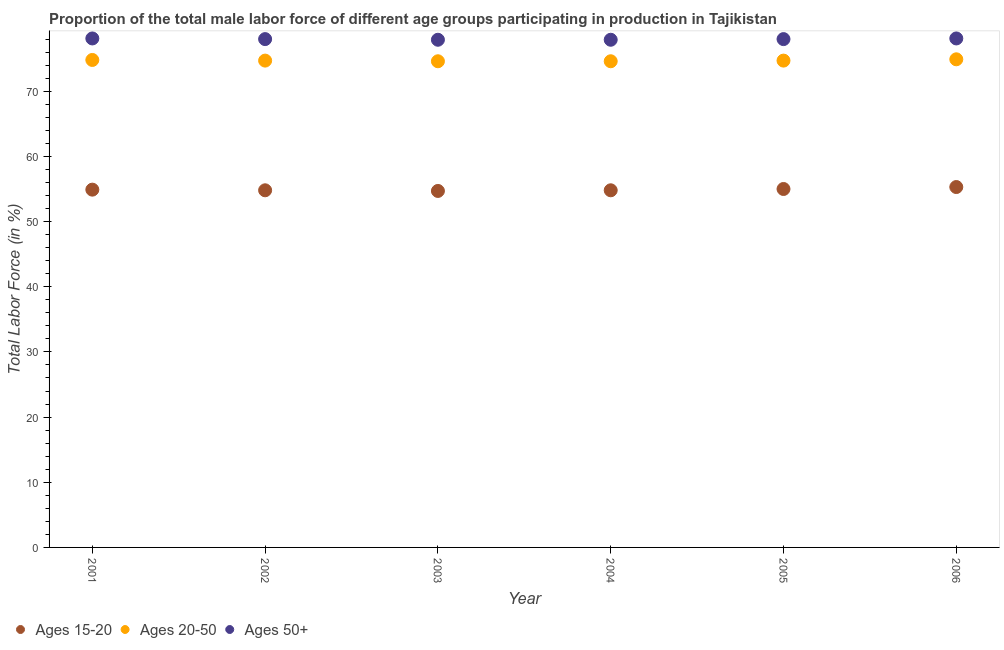What is the percentage of male labor force within the age group 15-20 in 2001?
Ensure brevity in your answer.  54.9. Across all years, what is the maximum percentage of male labor force above age 50?
Provide a short and direct response. 78.1. Across all years, what is the minimum percentage of male labor force above age 50?
Keep it short and to the point. 77.9. In which year was the percentage of male labor force above age 50 maximum?
Make the answer very short. 2001. In which year was the percentage of male labor force above age 50 minimum?
Provide a succinct answer. 2003. What is the total percentage of male labor force above age 50 in the graph?
Offer a terse response. 468. What is the difference between the percentage of male labor force within the age group 15-20 in 2001 and the percentage of male labor force within the age group 20-50 in 2002?
Provide a short and direct response. -19.8. What is the average percentage of male labor force within the age group 20-50 per year?
Keep it short and to the point. 74.72. In the year 2006, what is the difference between the percentage of male labor force within the age group 15-20 and percentage of male labor force within the age group 20-50?
Make the answer very short. -19.6. What is the ratio of the percentage of male labor force within the age group 20-50 in 2004 to that in 2005?
Offer a very short reply. 1. What is the difference between the highest and the second highest percentage of male labor force within the age group 15-20?
Your response must be concise. 0.3. What is the difference between the highest and the lowest percentage of male labor force above age 50?
Offer a very short reply. 0.2. In how many years, is the percentage of male labor force above age 50 greater than the average percentage of male labor force above age 50 taken over all years?
Give a very brief answer. 4. Is it the case that in every year, the sum of the percentage of male labor force within the age group 15-20 and percentage of male labor force within the age group 20-50 is greater than the percentage of male labor force above age 50?
Make the answer very short. Yes. Is the percentage of male labor force within the age group 15-20 strictly greater than the percentage of male labor force above age 50 over the years?
Your answer should be compact. No. How many dotlines are there?
Keep it short and to the point. 3. What is the difference between two consecutive major ticks on the Y-axis?
Your answer should be very brief. 10. Are the values on the major ticks of Y-axis written in scientific E-notation?
Offer a very short reply. No. Does the graph contain any zero values?
Offer a terse response. No. Does the graph contain grids?
Ensure brevity in your answer.  No. What is the title of the graph?
Your answer should be compact. Proportion of the total male labor force of different age groups participating in production in Tajikistan. What is the Total Labor Force (in %) in Ages 15-20 in 2001?
Offer a very short reply. 54.9. What is the Total Labor Force (in %) of Ages 20-50 in 2001?
Make the answer very short. 74.8. What is the Total Labor Force (in %) in Ages 50+ in 2001?
Offer a very short reply. 78.1. What is the Total Labor Force (in %) of Ages 15-20 in 2002?
Your answer should be compact. 54.8. What is the Total Labor Force (in %) in Ages 20-50 in 2002?
Provide a succinct answer. 74.7. What is the Total Labor Force (in %) of Ages 15-20 in 2003?
Your answer should be compact. 54.7. What is the Total Labor Force (in %) of Ages 20-50 in 2003?
Give a very brief answer. 74.6. What is the Total Labor Force (in %) in Ages 50+ in 2003?
Keep it short and to the point. 77.9. What is the Total Labor Force (in %) in Ages 15-20 in 2004?
Give a very brief answer. 54.8. What is the Total Labor Force (in %) in Ages 20-50 in 2004?
Offer a terse response. 74.6. What is the Total Labor Force (in %) in Ages 50+ in 2004?
Keep it short and to the point. 77.9. What is the Total Labor Force (in %) in Ages 20-50 in 2005?
Keep it short and to the point. 74.7. What is the Total Labor Force (in %) in Ages 15-20 in 2006?
Give a very brief answer. 55.3. What is the Total Labor Force (in %) in Ages 20-50 in 2006?
Your response must be concise. 74.9. What is the Total Labor Force (in %) of Ages 50+ in 2006?
Your answer should be very brief. 78.1. Across all years, what is the maximum Total Labor Force (in %) of Ages 15-20?
Your response must be concise. 55.3. Across all years, what is the maximum Total Labor Force (in %) in Ages 20-50?
Offer a very short reply. 74.9. Across all years, what is the maximum Total Labor Force (in %) in Ages 50+?
Provide a short and direct response. 78.1. Across all years, what is the minimum Total Labor Force (in %) of Ages 15-20?
Make the answer very short. 54.7. Across all years, what is the minimum Total Labor Force (in %) in Ages 20-50?
Offer a terse response. 74.6. Across all years, what is the minimum Total Labor Force (in %) of Ages 50+?
Provide a succinct answer. 77.9. What is the total Total Labor Force (in %) in Ages 15-20 in the graph?
Your answer should be compact. 329.5. What is the total Total Labor Force (in %) in Ages 20-50 in the graph?
Your answer should be very brief. 448.3. What is the total Total Labor Force (in %) of Ages 50+ in the graph?
Keep it short and to the point. 468. What is the difference between the Total Labor Force (in %) of Ages 15-20 in 2001 and that in 2002?
Give a very brief answer. 0.1. What is the difference between the Total Labor Force (in %) in Ages 50+ in 2001 and that in 2002?
Provide a succinct answer. 0.1. What is the difference between the Total Labor Force (in %) in Ages 50+ in 2001 and that in 2003?
Provide a short and direct response. 0.2. What is the difference between the Total Labor Force (in %) in Ages 20-50 in 2001 and that in 2004?
Keep it short and to the point. 0.2. What is the difference between the Total Labor Force (in %) of Ages 15-20 in 2001 and that in 2005?
Ensure brevity in your answer.  -0.1. What is the difference between the Total Labor Force (in %) in Ages 20-50 in 2001 and that in 2005?
Provide a succinct answer. 0.1. What is the difference between the Total Labor Force (in %) in Ages 50+ in 2001 and that in 2005?
Your response must be concise. 0.1. What is the difference between the Total Labor Force (in %) in Ages 20-50 in 2001 and that in 2006?
Provide a succinct answer. -0.1. What is the difference between the Total Labor Force (in %) of Ages 50+ in 2001 and that in 2006?
Offer a very short reply. 0. What is the difference between the Total Labor Force (in %) in Ages 50+ in 2002 and that in 2004?
Your response must be concise. 0.1. What is the difference between the Total Labor Force (in %) of Ages 15-20 in 2002 and that in 2005?
Your answer should be very brief. -0.2. What is the difference between the Total Labor Force (in %) of Ages 20-50 in 2002 and that in 2005?
Make the answer very short. 0. What is the difference between the Total Labor Force (in %) in Ages 20-50 in 2002 and that in 2006?
Your answer should be compact. -0.2. What is the difference between the Total Labor Force (in %) in Ages 50+ in 2002 and that in 2006?
Ensure brevity in your answer.  -0.1. What is the difference between the Total Labor Force (in %) of Ages 20-50 in 2003 and that in 2004?
Ensure brevity in your answer.  0. What is the difference between the Total Labor Force (in %) of Ages 15-20 in 2003 and that in 2006?
Make the answer very short. -0.6. What is the difference between the Total Labor Force (in %) of Ages 20-50 in 2003 and that in 2006?
Your answer should be compact. -0.3. What is the difference between the Total Labor Force (in %) of Ages 50+ in 2003 and that in 2006?
Your answer should be very brief. -0.2. What is the difference between the Total Labor Force (in %) in Ages 15-20 in 2004 and that in 2005?
Give a very brief answer. -0.2. What is the difference between the Total Labor Force (in %) in Ages 20-50 in 2004 and that in 2005?
Ensure brevity in your answer.  -0.1. What is the difference between the Total Labor Force (in %) in Ages 20-50 in 2004 and that in 2006?
Offer a very short reply. -0.3. What is the difference between the Total Labor Force (in %) of Ages 50+ in 2004 and that in 2006?
Provide a short and direct response. -0.2. What is the difference between the Total Labor Force (in %) in Ages 15-20 in 2001 and the Total Labor Force (in %) in Ages 20-50 in 2002?
Give a very brief answer. -19.8. What is the difference between the Total Labor Force (in %) in Ages 15-20 in 2001 and the Total Labor Force (in %) in Ages 50+ in 2002?
Your response must be concise. -23.1. What is the difference between the Total Labor Force (in %) in Ages 20-50 in 2001 and the Total Labor Force (in %) in Ages 50+ in 2002?
Provide a succinct answer. -3.2. What is the difference between the Total Labor Force (in %) in Ages 15-20 in 2001 and the Total Labor Force (in %) in Ages 20-50 in 2003?
Make the answer very short. -19.7. What is the difference between the Total Labor Force (in %) of Ages 15-20 in 2001 and the Total Labor Force (in %) of Ages 50+ in 2003?
Give a very brief answer. -23. What is the difference between the Total Labor Force (in %) of Ages 20-50 in 2001 and the Total Labor Force (in %) of Ages 50+ in 2003?
Your response must be concise. -3.1. What is the difference between the Total Labor Force (in %) in Ages 15-20 in 2001 and the Total Labor Force (in %) in Ages 20-50 in 2004?
Your response must be concise. -19.7. What is the difference between the Total Labor Force (in %) of Ages 20-50 in 2001 and the Total Labor Force (in %) of Ages 50+ in 2004?
Your answer should be very brief. -3.1. What is the difference between the Total Labor Force (in %) of Ages 15-20 in 2001 and the Total Labor Force (in %) of Ages 20-50 in 2005?
Provide a short and direct response. -19.8. What is the difference between the Total Labor Force (in %) of Ages 15-20 in 2001 and the Total Labor Force (in %) of Ages 50+ in 2005?
Provide a succinct answer. -23.1. What is the difference between the Total Labor Force (in %) in Ages 15-20 in 2001 and the Total Labor Force (in %) in Ages 50+ in 2006?
Give a very brief answer. -23.2. What is the difference between the Total Labor Force (in %) in Ages 20-50 in 2001 and the Total Labor Force (in %) in Ages 50+ in 2006?
Your response must be concise. -3.3. What is the difference between the Total Labor Force (in %) of Ages 15-20 in 2002 and the Total Labor Force (in %) of Ages 20-50 in 2003?
Offer a very short reply. -19.8. What is the difference between the Total Labor Force (in %) of Ages 15-20 in 2002 and the Total Labor Force (in %) of Ages 50+ in 2003?
Your answer should be very brief. -23.1. What is the difference between the Total Labor Force (in %) of Ages 15-20 in 2002 and the Total Labor Force (in %) of Ages 20-50 in 2004?
Keep it short and to the point. -19.8. What is the difference between the Total Labor Force (in %) in Ages 15-20 in 2002 and the Total Labor Force (in %) in Ages 50+ in 2004?
Your response must be concise. -23.1. What is the difference between the Total Labor Force (in %) of Ages 15-20 in 2002 and the Total Labor Force (in %) of Ages 20-50 in 2005?
Provide a succinct answer. -19.9. What is the difference between the Total Labor Force (in %) in Ages 15-20 in 2002 and the Total Labor Force (in %) in Ages 50+ in 2005?
Ensure brevity in your answer.  -23.2. What is the difference between the Total Labor Force (in %) of Ages 20-50 in 2002 and the Total Labor Force (in %) of Ages 50+ in 2005?
Ensure brevity in your answer.  -3.3. What is the difference between the Total Labor Force (in %) in Ages 15-20 in 2002 and the Total Labor Force (in %) in Ages 20-50 in 2006?
Offer a terse response. -20.1. What is the difference between the Total Labor Force (in %) in Ages 15-20 in 2002 and the Total Labor Force (in %) in Ages 50+ in 2006?
Offer a very short reply. -23.3. What is the difference between the Total Labor Force (in %) of Ages 20-50 in 2002 and the Total Labor Force (in %) of Ages 50+ in 2006?
Keep it short and to the point. -3.4. What is the difference between the Total Labor Force (in %) in Ages 15-20 in 2003 and the Total Labor Force (in %) in Ages 20-50 in 2004?
Ensure brevity in your answer.  -19.9. What is the difference between the Total Labor Force (in %) in Ages 15-20 in 2003 and the Total Labor Force (in %) in Ages 50+ in 2004?
Your response must be concise. -23.2. What is the difference between the Total Labor Force (in %) of Ages 20-50 in 2003 and the Total Labor Force (in %) of Ages 50+ in 2004?
Keep it short and to the point. -3.3. What is the difference between the Total Labor Force (in %) in Ages 15-20 in 2003 and the Total Labor Force (in %) in Ages 20-50 in 2005?
Your response must be concise. -20. What is the difference between the Total Labor Force (in %) of Ages 15-20 in 2003 and the Total Labor Force (in %) of Ages 50+ in 2005?
Your answer should be compact. -23.3. What is the difference between the Total Labor Force (in %) in Ages 20-50 in 2003 and the Total Labor Force (in %) in Ages 50+ in 2005?
Provide a short and direct response. -3.4. What is the difference between the Total Labor Force (in %) of Ages 15-20 in 2003 and the Total Labor Force (in %) of Ages 20-50 in 2006?
Provide a succinct answer. -20.2. What is the difference between the Total Labor Force (in %) of Ages 15-20 in 2003 and the Total Labor Force (in %) of Ages 50+ in 2006?
Your answer should be compact. -23.4. What is the difference between the Total Labor Force (in %) in Ages 20-50 in 2003 and the Total Labor Force (in %) in Ages 50+ in 2006?
Keep it short and to the point. -3.5. What is the difference between the Total Labor Force (in %) of Ages 15-20 in 2004 and the Total Labor Force (in %) of Ages 20-50 in 2005?
Give a very brief answer. -19.9. What is the difference between the Total Labor Force (in %) in Ages 15-20 in 2004 and the Total Labor Force (in %) in Ages 50+ in 2005?
Your answer should be very brief. -23.2. What is the difference between the Total Labor Force (in %) in Ages 20-50 in 2004 and the Total Labor Force (in %) in Ages 50+ in 2005?
Make the answer very short. -3.4. What is the difference between the Total Labor Force (in %) in Ages 15-20 in 2004 and the Total Labor Force (in %) in Ages 20-50 in 2006?
Your answer should be very brief. -20.1. What is the difference between the Total Labor Force (in %) in Ages 15-20 in 2004 and the Total Labor Force (in %) in Ages 50+ in 2006?
Your answer should be very brief. -23.3. What is the difference between the Total Labor Force (in %) in Ages 20-50 in 2004 and the Total Labor Force (in %) in Ages 50+ in 2006?
Provide a short and direct response. -3.5. What is the difference between the Total Labor Force (in %) in Ages 15-20 in 2005 and the Total Labor Force (in %) in Ages 20-50 in 2006?
Provide a succinct answer. -19.9. What is the difference between the Total Labor Force (in %) in Ages 15-20 in 2005 and the Total Labor Force (in %) in Ages 50+ in 2006?
Make the answer very short. -23.1. What is the difference between the Total Labor Force (in %) in Ages 20-50 in 2005 and the Total Labor Force (in %) in Ages 50+ in 2006?
Ensure brevity in your answer.  -3.4. What is the average Total Labor Force (in %) in Ages 15-20 per year?
Give a very brief answer. 54.92. What is the average Total Labor Force (in %) in Ages 20-50 per year?
Give a very brief answer. 74.72. In the year 2001, what is the difference between the Total Labor Force (in %) in Ages 15-20 and Total Labor Force (in %) in Ages 20-50?
Your answer should be compact. -19.9. In the year 2001, what is the difference between the Total Labor Force (in %) in Ages 15-20 and Total Labor Force (in %) in Ages 50+?
Give a very brief answer. -23.2. In the year 2001, what is the difference between the Total Labor Force (in %) in Ages 20-50 and Total Labor Force (in %) in Ages 50+?
Your answer should be compact. -3.3. In the year 2002, what is the difference between the Total Labor Force (in %) in Ages 15-20 and Total Labor Force (in %) in Ages 20-50?
Offer a very short reply. -19.9. In the year 2002, what is the difference between the Total Labor Force (in %) in Ages 15-20 and Total Labor Force (in %) in Ages 50+?
Offer a terse response. -23.2. In the year 2002, what is the difference between the Total Labor Force (in %) in Ages 20-50 and Total Labor Force (in %) in Ages 50+?
Your answer should be compact. -3.3. In the year 2003, what is the difference between the Total Labor Force (in %) of Ages 15-20 and Total Labor Force (in %) of Ages 20-50?
Ensure brevity in your answer.  -19.9. In the year 2003, what is the difference between the Total Labor Force (in %) of Ages 15-20 and Total Labor Force (in %) of Ages 50+?
Offer a very short reply. -23.2. In the year 2004, what is the difference between the Total Labor Force (in %) of Ages 15-20 and Total Labor Force (in %) of Ages 20-50?
Offer a very short reply. -19.8. In the year 2004, what is the difference between the Total Labor Force (in %) in Ages 15-20 and Total Labor Force (in %) in Ages 50+?
Provide a succinct answer. -23.1. In the year 2004, what is the difference between the Total Labor Force (in %) of Ages 20-50 and Total Labor Force (in %) of Ages 50+?
Provide a succinct answer. -3.3. In the year 2005, what is the difference between the Total Labor Force (in %) in Ages 15-20 and Total Labor Force (in %) in Ages 20-50?
Offer a terse response. -19.7. In the year 2006, what is the difference between the Total Labor Force (in %) in Ages 15-20 and Total Labor Force (in %) in Ages 20-50?
Ensure brevity in your answer.  -19.6. In the year 2006, what is the difference between the Total Labor Force (in %) in Ages 15-20 and Total Labor Force (in %) in Ages 50+?
Give a very brief answer. -22.8. In the year 2006, what is the difference between the Total Labor Force (in %) of Ages 20-50 and Total Labor Force (in %) of Ages 50+?
Provide a short and direct response. -3.2. What is the ratio of the Total Labor Force (in %) in Ages 15-20 in 2001 to that in 2002?
Keep it short and to the point. 1. What is the ratio of the Total Labor Force (in %) in Ages 20-50 in 2001 to that in 2002?
Provide a short and direct response. 1. What is the ratio of the Total Labor Force (in %) in Ages 20-50 in 2001 to that in 2003?
Ensure brevity in your answer.  1. What is the ratio of the Total Labor Force (in %) in Ages 50+ in 2001 to that in 2003?
Give a very brief answer. 1. What is the ratio of the Total Labor Force (in %) in Ages 15-20 in 2001 to that in 2005?
Offer a very short reply. 1. What is the ratio of the Total Labor Force (in %) of Ages 50+ in 2001 to that in 2005?
Provide a succinct answer. 1. What is the ratio of the Total Labor Force (in %) in Ages 15-20 in 2001 to that in 2006?
Your answer should be very brief. 0.99. What is the ratio of the Total Labor Force (in %) in Ages 20-50 in 2001 to that in 2006?
Offer a terse response. 1. What is the ratio of the Total Labor Force (in %) of Ages 50+ in 2001 to that in 2006?
Provide a succinct answer. 1. What is the ratio of the Total Labor Force (in %) of Ages 15-20 in 2002 to that in 2003?
Provide a short and direct response. 1. What is the ratio of the Total Labor Force (in %) of Ages 15-20 in 2002 to that in 2004?
Provide a short and direct response. 1. What is the ratio of the Total Labor Force (in %) in Ages 20-50 in 2002 to that in 2004?
Your response must be concise. 1. What is the ratio of the Total Labor Force (in %) in Ages 20-50 in 2002 to that in 2005?
Your response must be concise. 1. What is the ratio of the Total Labor Force (in %) of Ages 15-20 in 2002 to that in 2006?
Your response must be concise. 0.99. What is the ratio of the Total Labor Force (in %) in Ages 20-50 in 2002 to that in 2006?
Make the answer very short. 1. What is the ratio of the Total Labor Force (in %) of Ages 50+ in 2002 to that in 2006?
Provide a short and direct response. 1. What is the ratio of the Total Labor Force (in %) of Ages 20-50 in 2003 to that in 2004?
Provide a short and direct response. 1. What is the ratio of the Total Labor Force (in %) in Ages 50+ in 2003 to that in 2004?
Your response must be concise. 1. What is the ratio of the Total Labor Force (in %) of Ages 20-50 in 2003 to that in 2005?
Your answer should be compact. 1. What is the ratio of the Total Labor Force (in %) in Ages 15-20 in 2004 to that in 2005?
Your answer should be very brief. 1. What is the ratio of the Total Labor Force (in %) of Ages 20-50 in 2004 to that in 2005?
Your answer should be compact. 1. What is the ratio of the Total Labor Force (in %) in Ages 20-50 in 2004 to that in 2006?
Provide a short and direct response. 1. What is the ratio of the Total Labor Force (in %) of Ages 50+ in 2004 to that in 2006?
Provide a succinct answer. 1. What is the ratio of the Total Labor Force (in %) of Ages 15-20 in 2005 to that in 2006?
Provide a succinct answer. 0.99. What is the ratio of the Total Labor Force (in %) in Ages 50+ in 2005 to that in 2006?
Your answer should be compact. 1. 